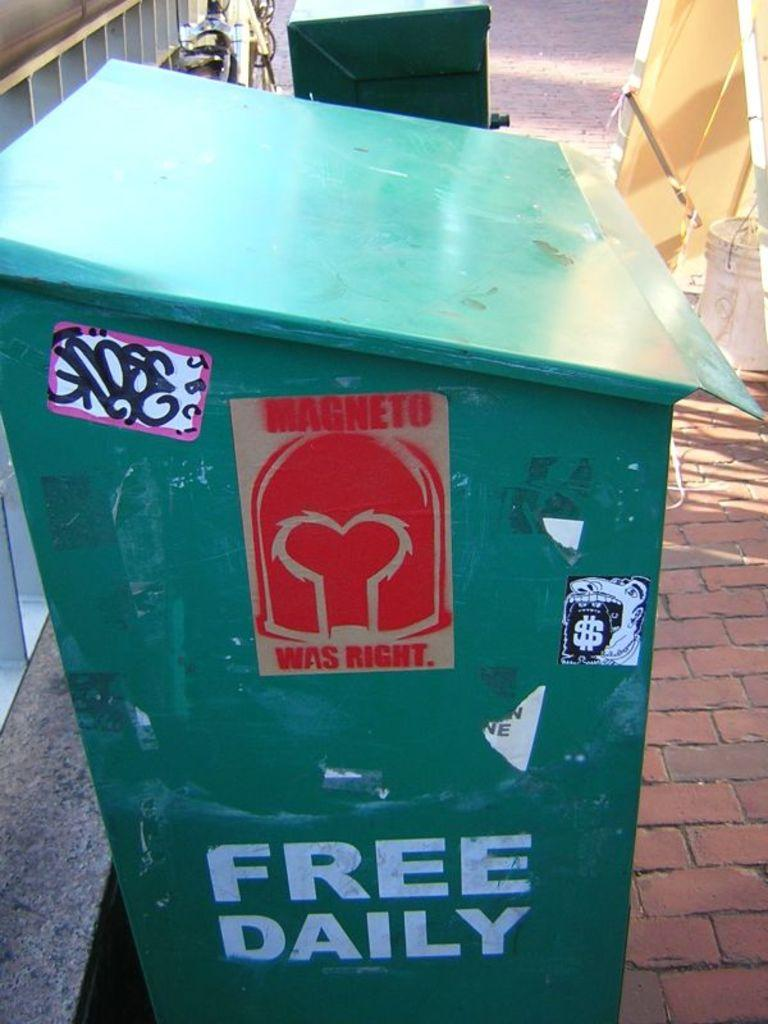What is present in the image that is used for holding items? There is a bin in the image that is used for holding items. Can you describe the appearance of the bin? The bin has stickers on it. Where is the bin located in the image? The bin is placed on the floor. What can be seen in the background of the image? There is a bucket and some objects in the background of the image. What type of wound can be seen on the bucket in the background of the image? There is no wound present on the bucket or any other item in the image. 